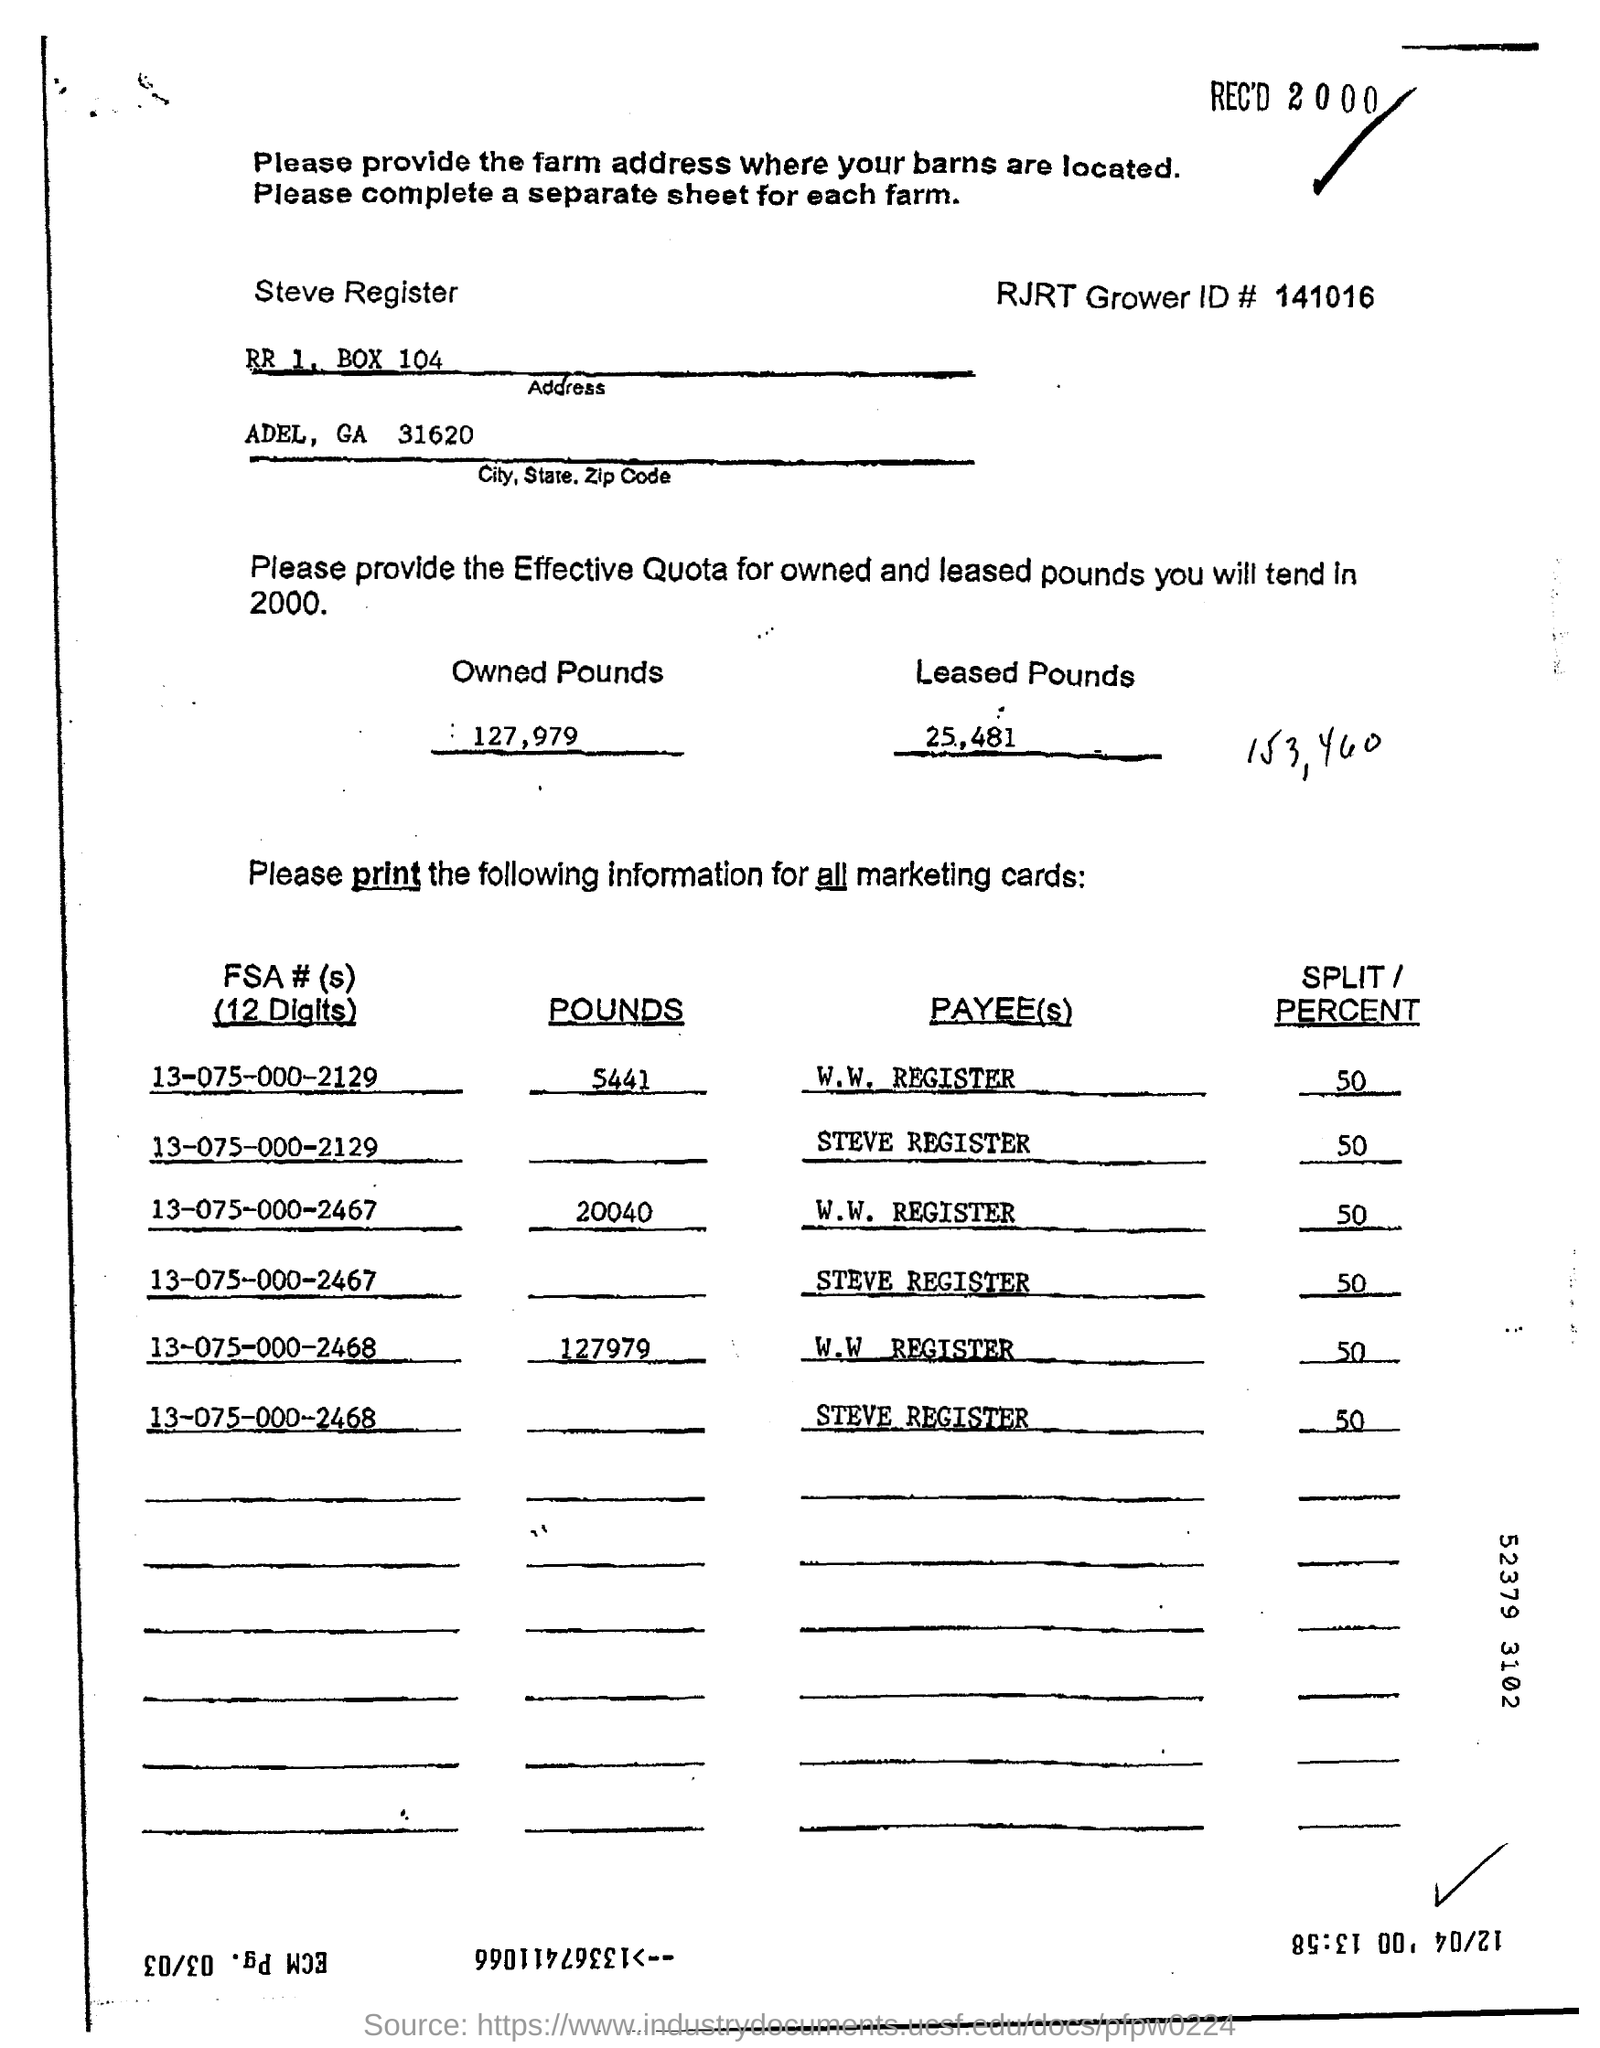List a handful of essential elements in this visual. The RJRT Grower ID# is 141016. 